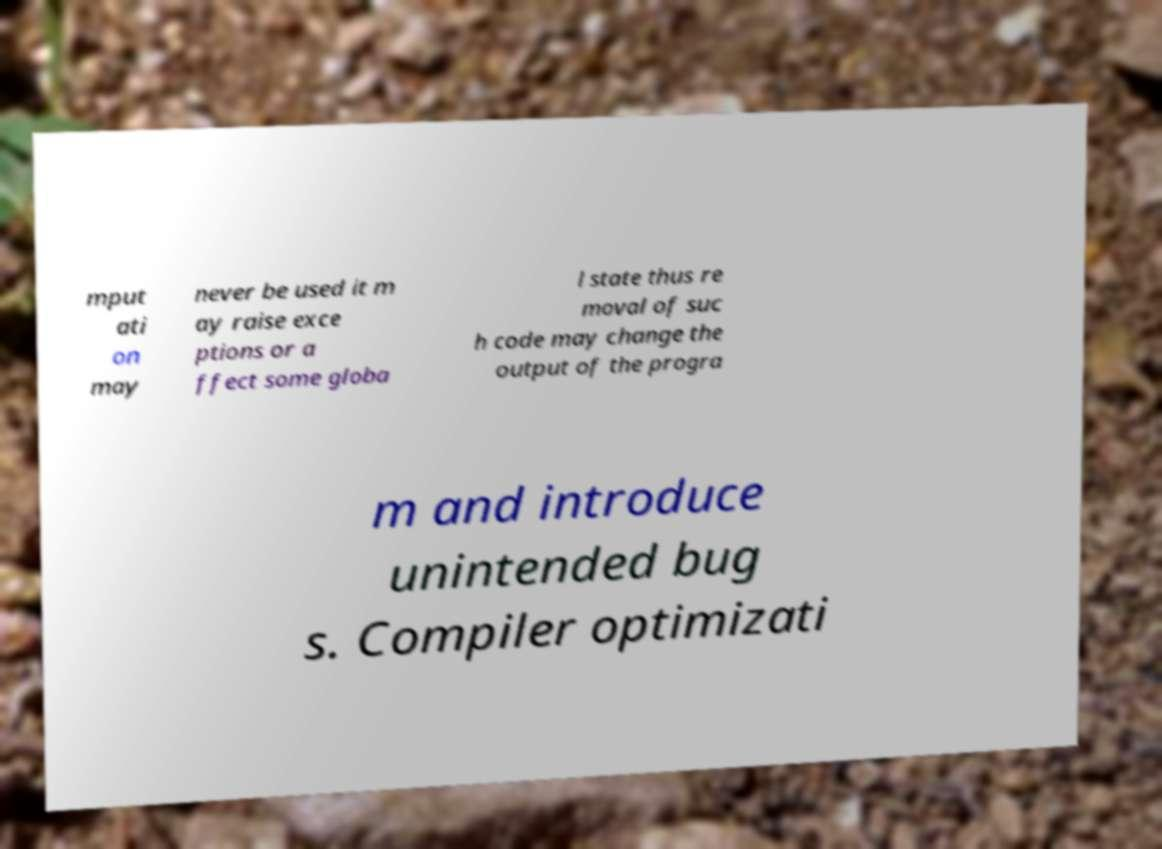Please read and relay the text visible in this image. What does it say? mput ati on may never be used it m ay raise exce ptions or a ffect some globa l state thus re moval of suc h code may change the output of the progra m and introduce unintended bug s. Compiler optimizati 